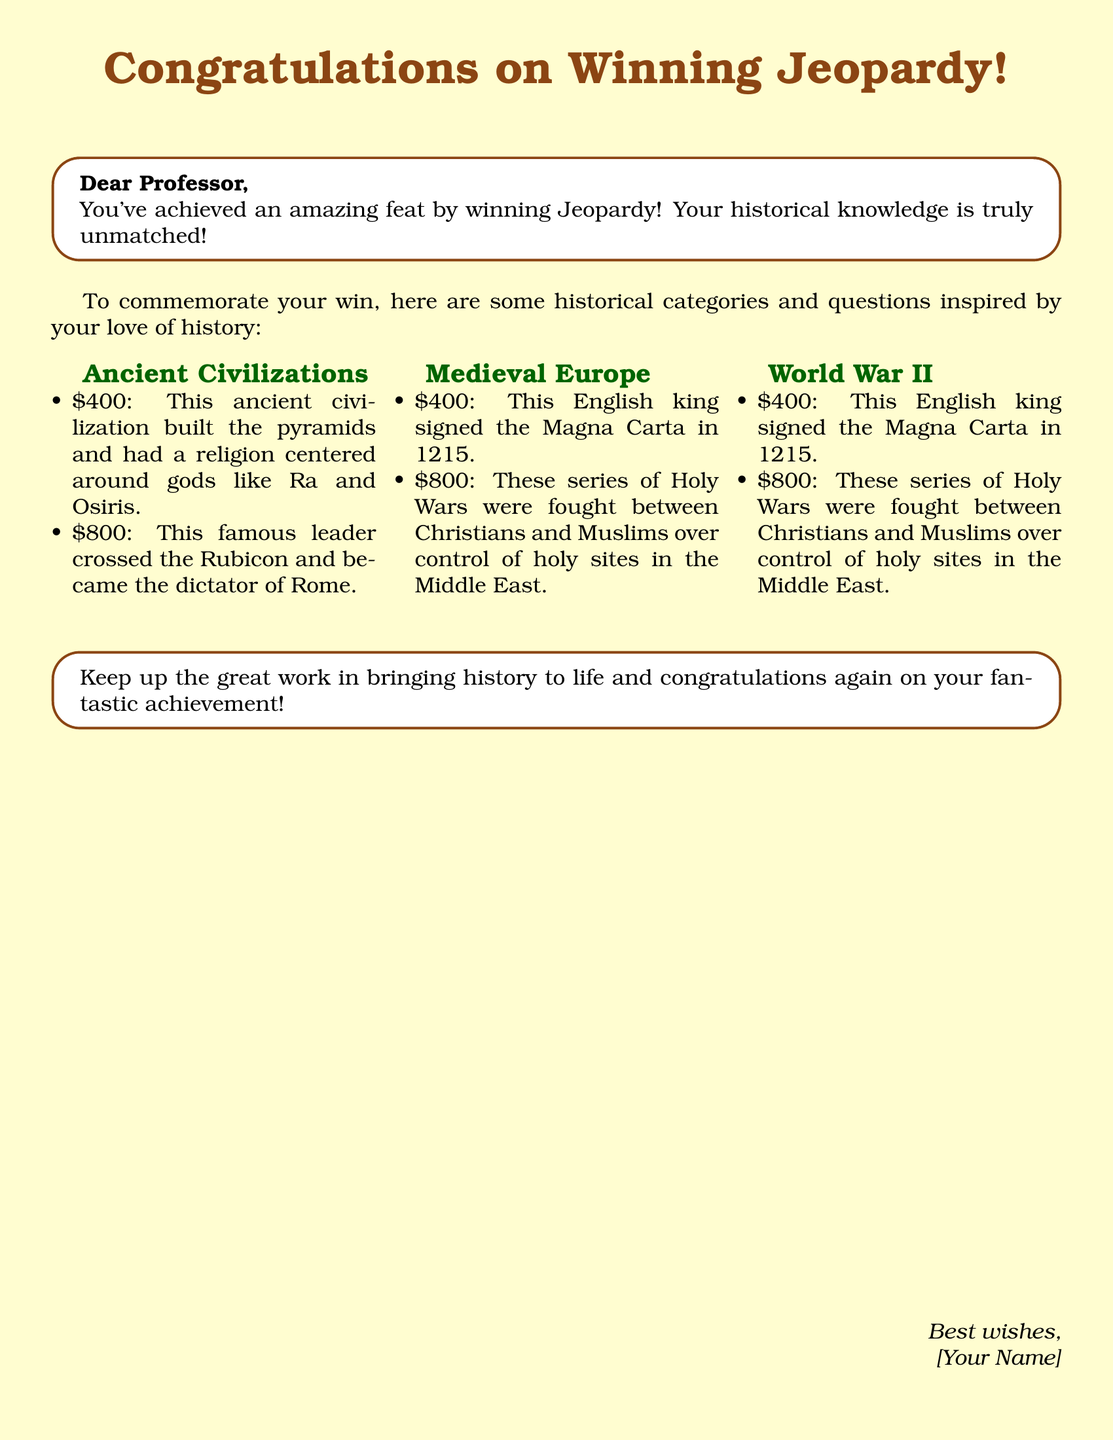What is the color of the card? The card has a background color defined in RGB format as 255, 253, 208.
Answer: light yellow Who is congratulated in the card? The greeting card addresses "Dear Professor," indicating that the professor is the recipient being congratulated.
Answer: Professor What event did the recipient win? The card states the recipient achieved "an amazing feat by winning Jeopardy!" hence the event in question is Jeopardy.
Answer: Jeopardy Which English king signed the Magna Carta? The card states the answer to this specific question as part of the Jeopardy-style question regarding Medieval Europe.
Answer: King John What major global event began in 1939? The document mentions this as part of the World War II category question, and the event is clearly stated within the text.
Answer: World War II What is the color of the title text? The title text has a defined color with RGB values, which can be identified in the document.
Answer: brown What is the prize amount for the question about the Rubicon? The document states the dollar value associated with this particular question is $800.
Answer: $800 What is the category of the question about the Pyramids? The question about the Pyramids falls under "Ancient Civilizations" as defined in the document.
Answer: Ancient Civilizations 